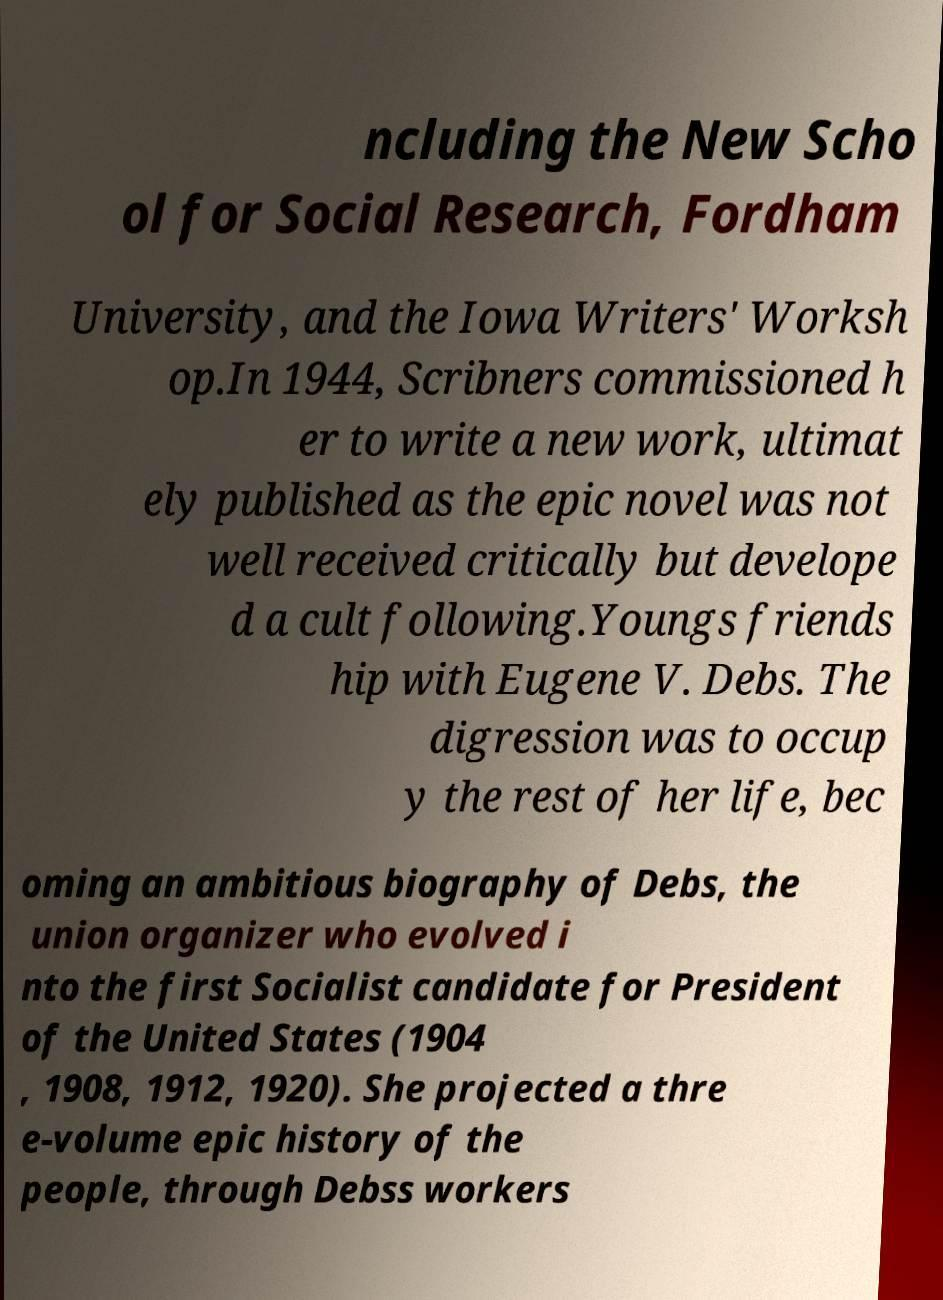Please identify and transcribe the text found in this image. ncluding the New Scho ol for Social Research, Fordham University, and the Iowa Writers' Worksh op.In 1944, Scribners commissioned h er to write a new work, ultimat ely published as the epic novel was not well received critically but develope d a cult following.Youngs friends hip with Eugene V. Debs. The digression was to occup y the rest of her life, bec oming an ambitious biography of Debs, the union organizer who evolved i nto the first Socialist candidate for President of the United States (1904 , 1908, 1912, 1920). She projected a thre e-volume epic history of the people, through Debss workers 